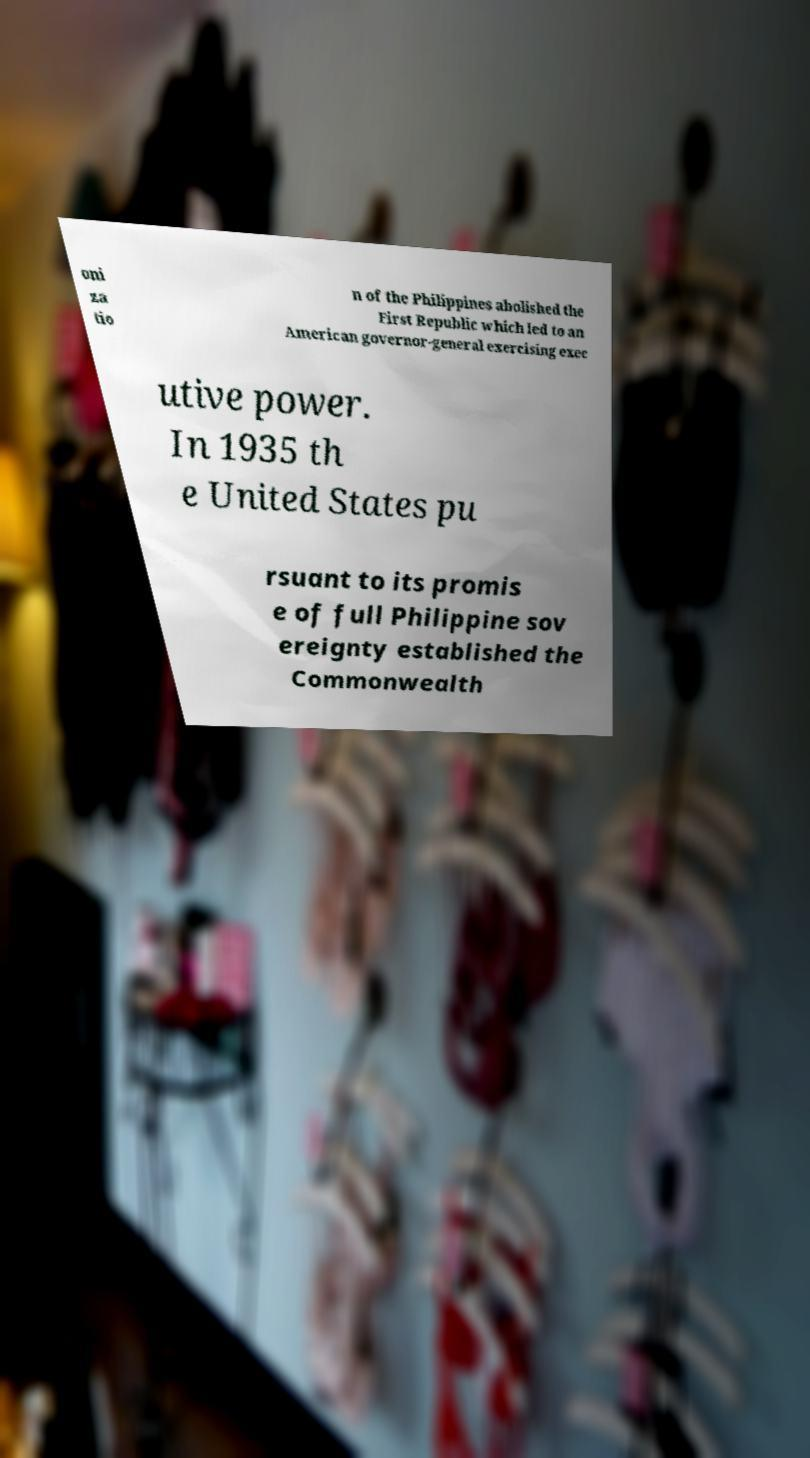What messages or text are displayed in this image? I need them in a readable, typed format. oni za tio n of the Philippines abolished the First Republic which led to an American governor-general exercising exec utive power. In 1935 th e United States pu rsuant to its promis e of full Philippine sov ereignty established the Commonwealth 